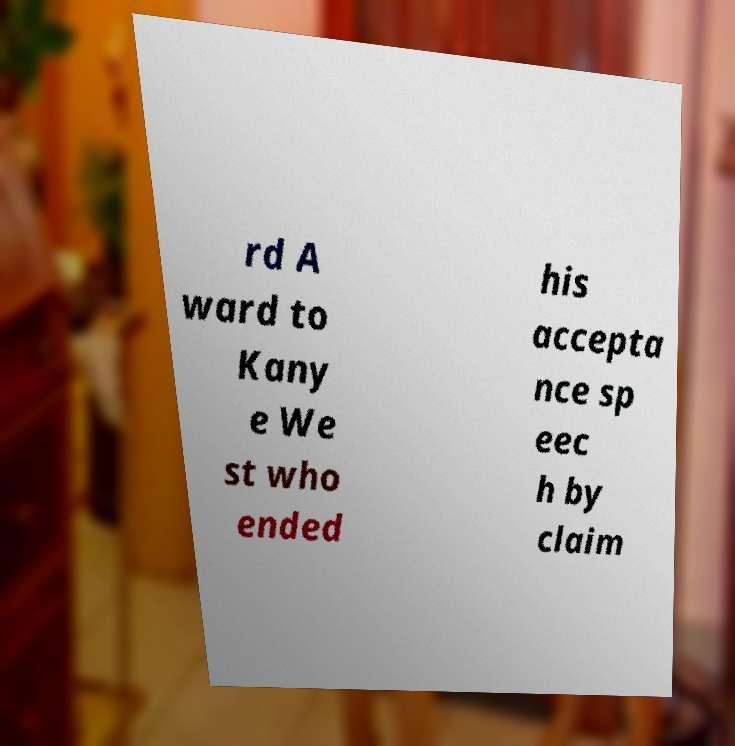Can you read and provide the text displayed in the image?This photo seems to have some interesting text. Can you extract and type it out for me? rd A ward to Kany e We st who ended his accepta nce sp eec h by claim 